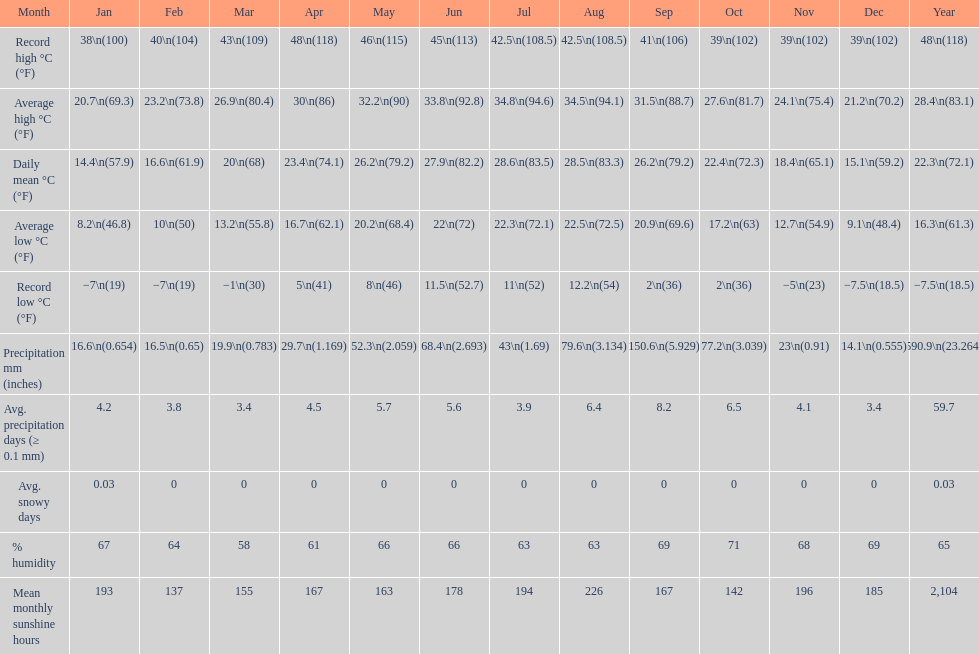Was there more precipitation in march or april? April. 